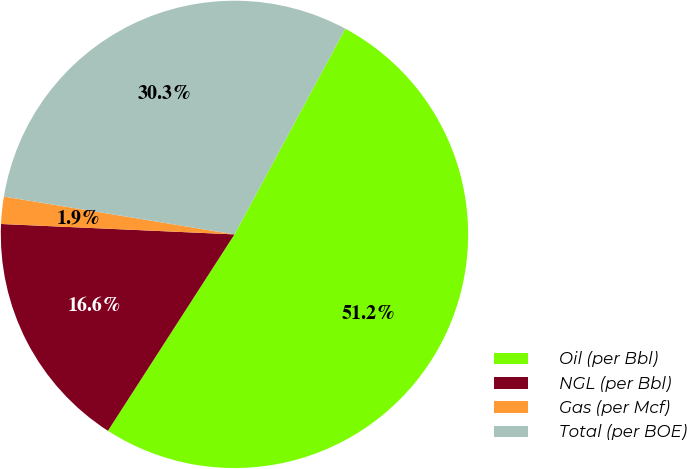Convert chart to OTSL. <chart><loc_0><loc_0><loc_500><loc_500><pie_chart><fcel>Oil (per Bbl)<fcel>NGL (per Bbl)<fcel>Gas (per Mcf)<fcel>Total (per BOE)<nl><fcel>51.25%<fcel>16.6%<fcel>1.88%<fcel>30.28%<nl></chart> 